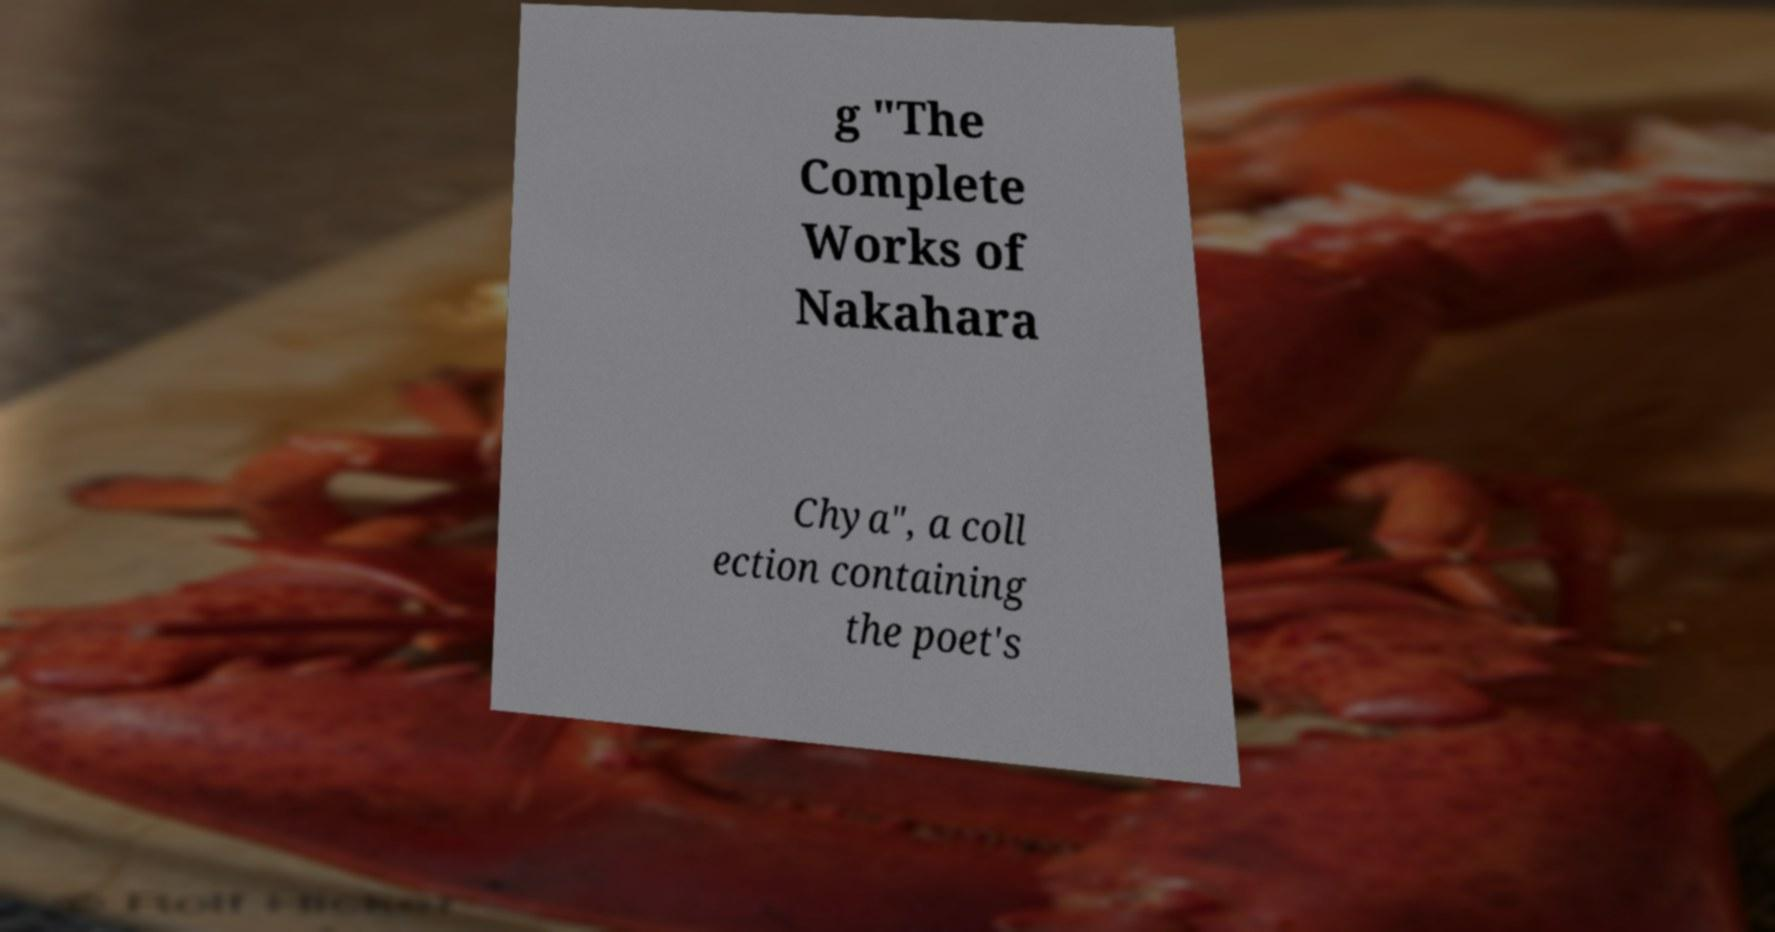I need the written content from this picture converted into text. Can you do that? g "The Complete Works of Nakahara Chya", a coll ection containing the poet's 